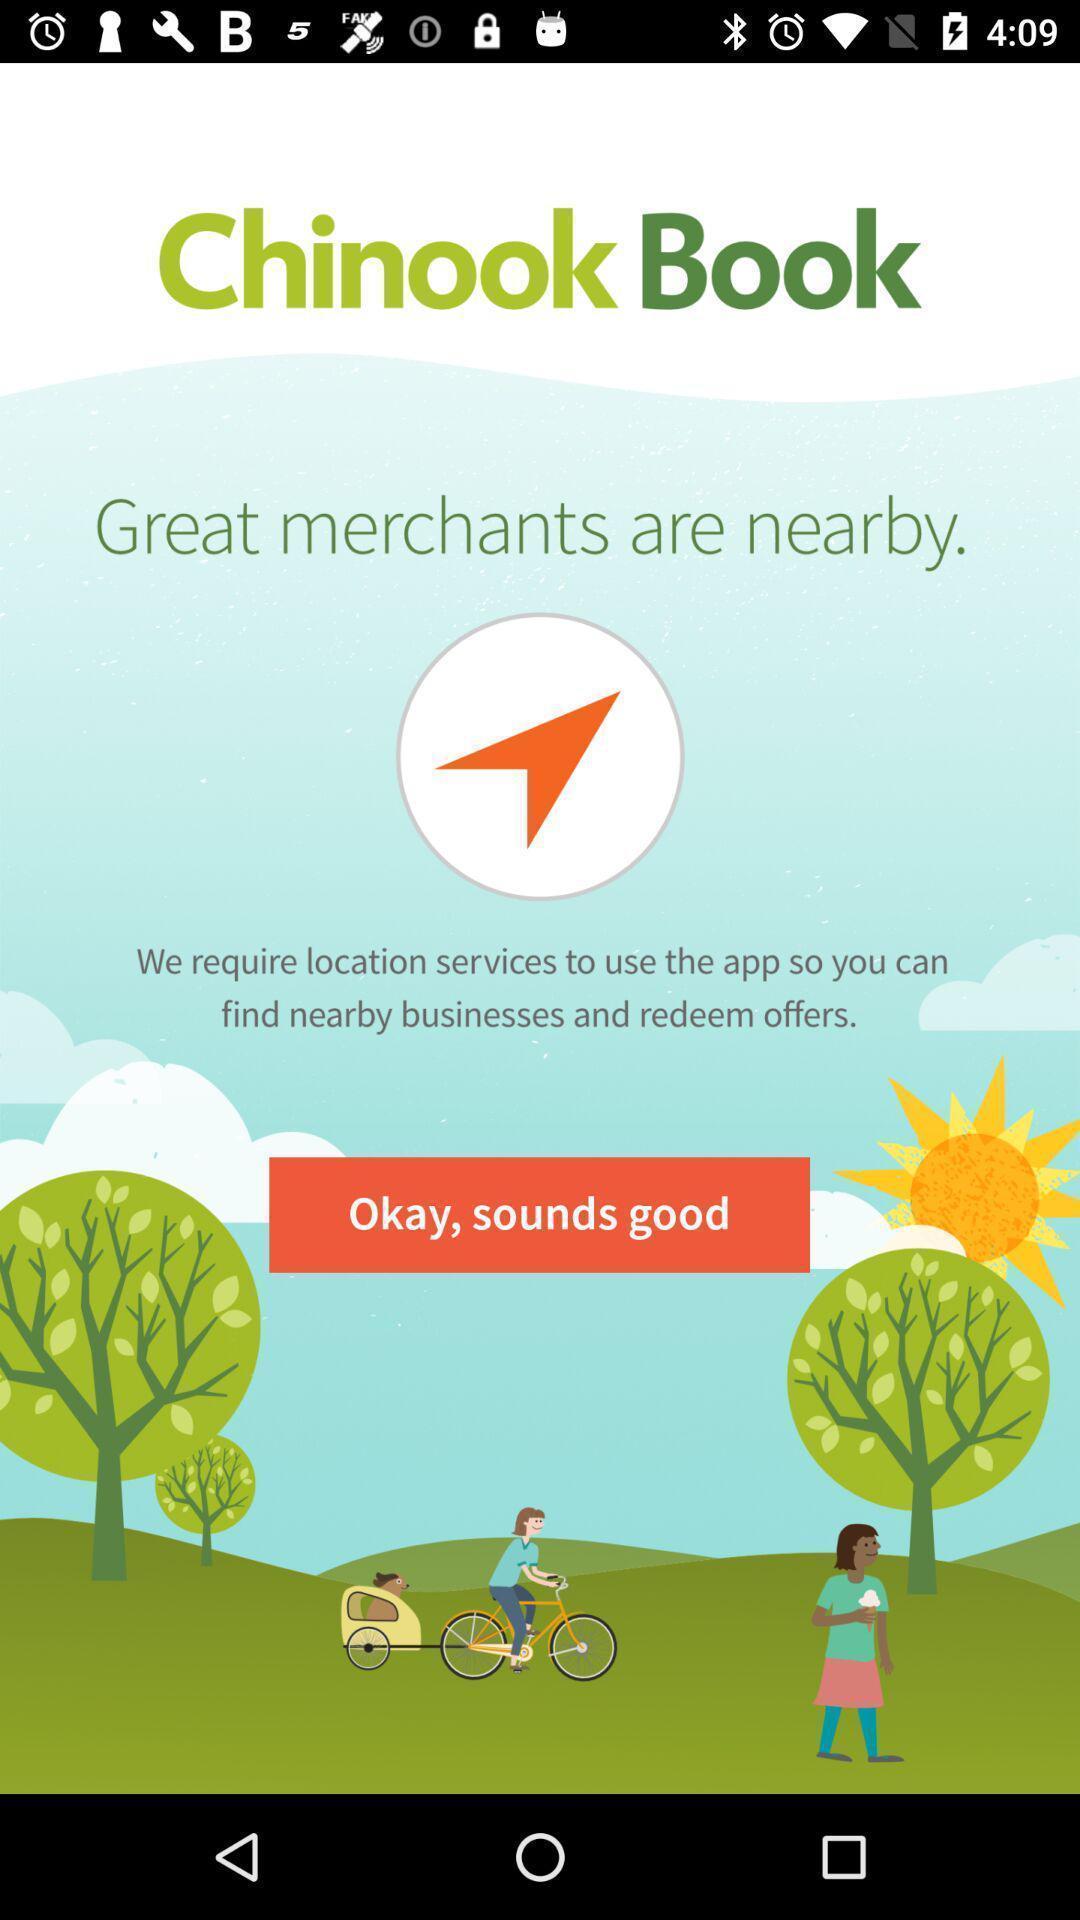Give me a narrative description of this picture. Welcome page of a merchant app. 